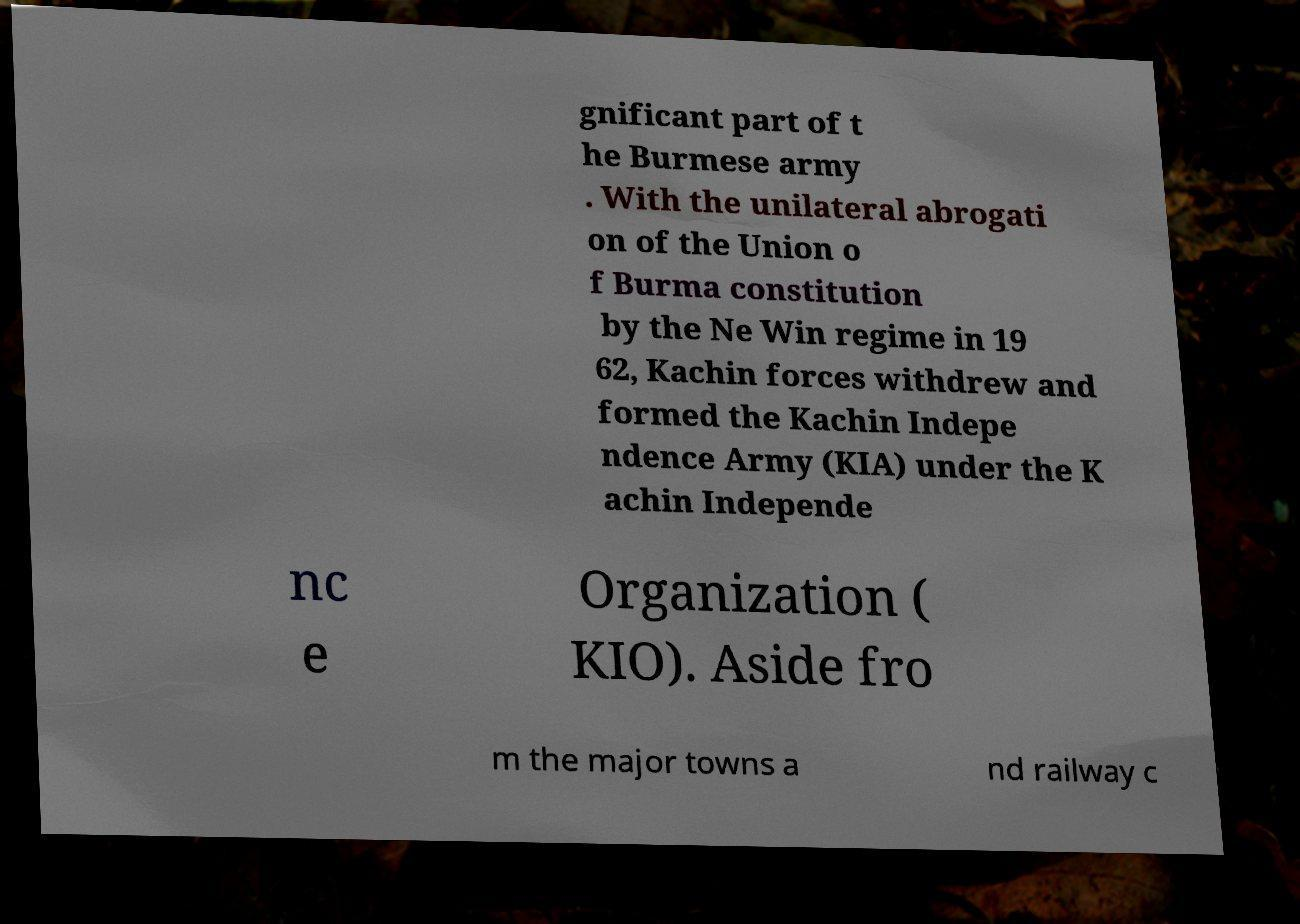What messages or text are displayed in this image? I need them in a readable, typed format. gnificant part of t he Burmese army . With the unilateral abrogati on of the Union o f Burma constitution by the Ne Win regime in 19 62, Kachin forces withdrew and formed the Kachin Indepe ndence Army (KIA) under the K achin Independe nc e Organization ( KIO). Aside fro m the major towns a nd railway c 